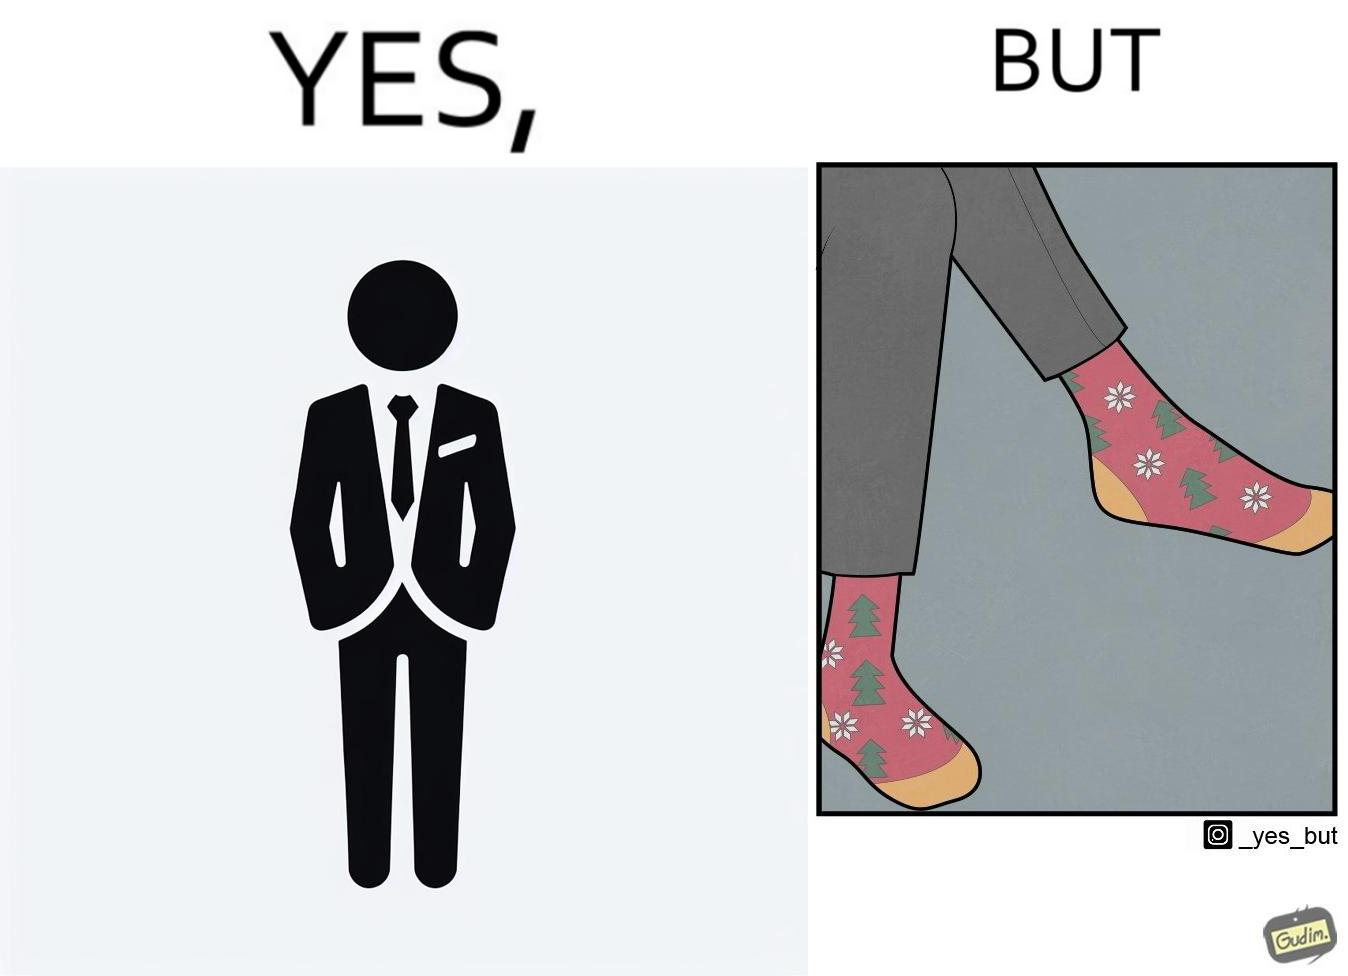Why is this image considered satirical? The image is ironical, as the person wearing a formal black suit and pants, is wearing colorful socks, probably due to the reason that socks are not visible while wearing shoes, and hence, do not need to be formal. 